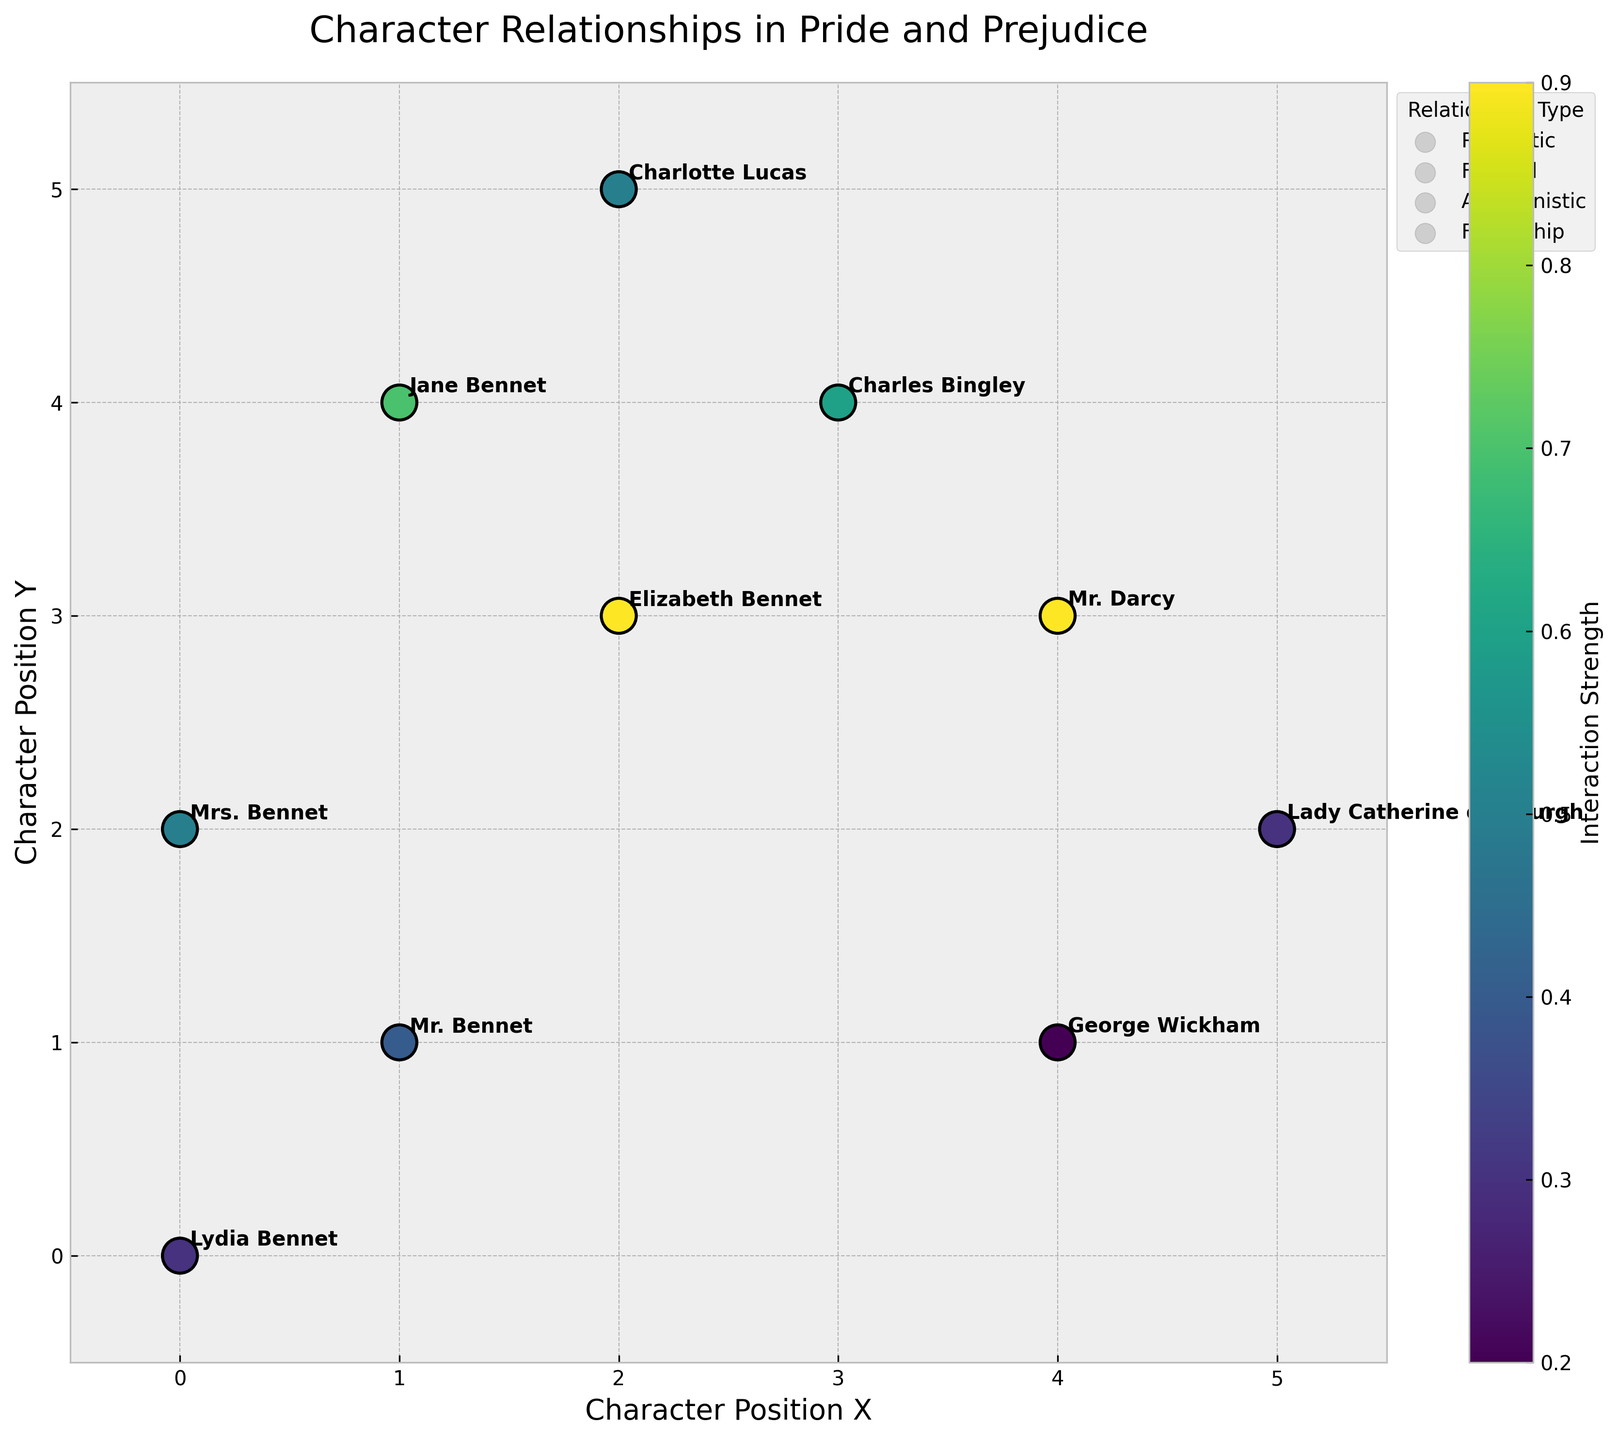What is the title of the plot? The title of the plot is displayed at the top of the figure. It provides an overview of what the plot represents.
Answer: Character Relationships in Pride and Prejudice Which character is located at position (4, 1)? The character located at position (4, 1) can be identified by checking the annotated names near the coordinates on the plot.
Answer: George Wickham How many characters have an interaction strength greater than 0.5? To determine the number of characters with an interaction strength greater than 0.5, count the number of points with a color indicating higher values in the colormap legend.
Answer: 4 What is the relationship type between Elizabeth Bennet and Mr. Darcy? The relationship type between two characters can be inferred from the color-coded relationship types in the legend and their specific interactions on the plot. Elizabeth Bennet and Mr. Darcy are shown to have the same strength and their Relationship_Type is listed in the data.
Answer: Romantic Which character has the highest interaction strength? The character with the highest interaction strength corresponds to the point with the darkest color in the colormap and largest vector length.
Answer: Elizabeth Bennet (and Mr. Darcy, tied) Comparing the interaction strengths of Jane Bennet and Charles Bingley, who has a stronger interaction? To compare the interaction strengths, look at the color intensity and vector lengths for Jane Bennet and Charles Bingley in the plot. Also, Jane Bennet's value (0.7) is greater than Charles Bingley’s value (0.6).
Answer: Jane Bennet What type of relationship does George Wickham have, based on the color legend? By comparing the color used to depict George Wickham’s interactions to the colors in the legend, the relationship type can be identified.
Answer: Antagonistic How many characters have a familial relationship type? Count the number of characters that appear under 'Familial' in the legend. Check which characters match this type in their annotations.
Answer: 4 Which character is furthest to the right on the plot? The character furthest to the right will have the highest X-coordinate value on the plot. Verification shows Lady Catherine de Bourgh is at (5, 2).
Answer: Lady Catherine de Bourgh 